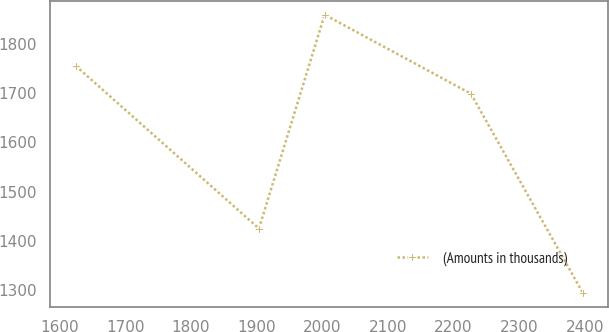<chart> <loc_0><loc_0><loc_500><loc_500><line_chart><ecel><fcel>(Amounts in thousands)<nl><fcel>1624.69<fcel>1755.82<nl><fcel>1903.8<fcel>1424.7<nl><fcel>2003.83<fcel>1860<nl><fcel>2226.71<fcel>1699.11<nl><fcel>2397.42<fcel>1292.9<nl></chart> 